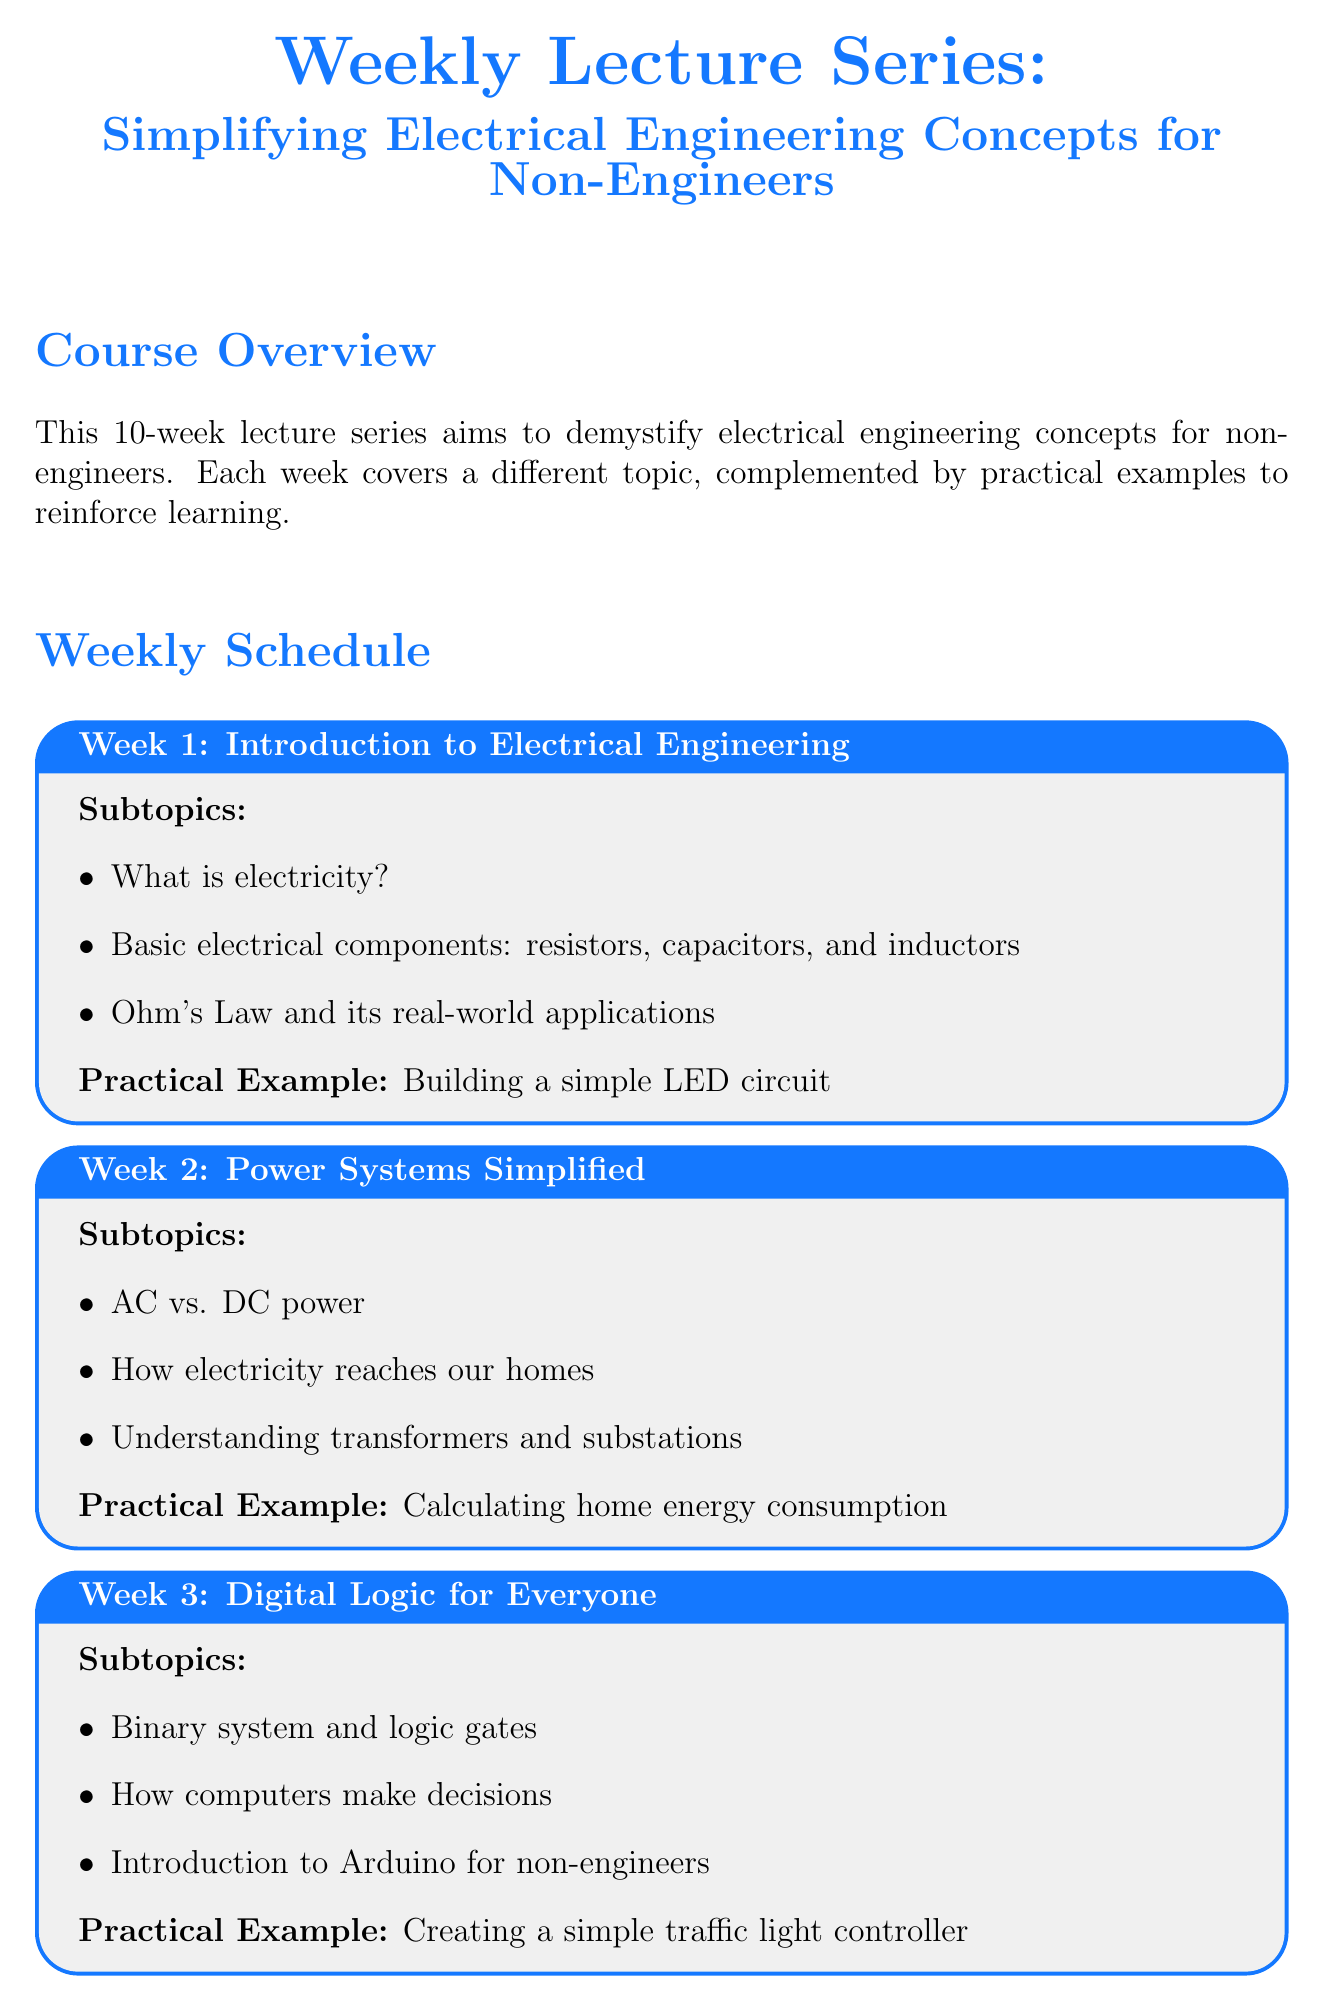What is the topic of Week 1? The document lists the topics for each week, and Week 1 is titled "Introduction to Electrical Engineering."
Answer: Introduction to Electrical Engineering What practical example is provided for Week 4? The practical examples for each week are outlined, with Week 4 showing "Measuring Wi-Fi signal strength in different locations."
Answer: Measuring Wi-Fi signal strength in different locations How many weeks does the lecture series cover? The document explicitly states that the lecture series is a 10-week program.
Answer: 10 What fundamental electrical component is introduced in Week 1? One of the subtopics in Week 1 is "Basic electrical components: resistors, capacitors, and inductors," which includes several fundamental components.
Answer: Resistors, capacitors, and inductors What technology is explained in Week 6? Week 6 covers "Renewable Energy Systems," including various technologies, one of which is solar panels.
Answer: Solar panel Which week discusses Electric Vehicles? The document specifies that Week 7 discusses topics related to electric vehicles.
Answer: Week 7 What is the goal of the lecture series? The course overview states that its aim is to demystify electrical engineering concepts for non-engineers.
Answer: Demystify electrical engineering concepts for non-engineers What additional resource provides video content? The document mentions a YouTube channel named "ElectroBOOM" as providing video content for the lectures.
Answer: ElectroBOOM 